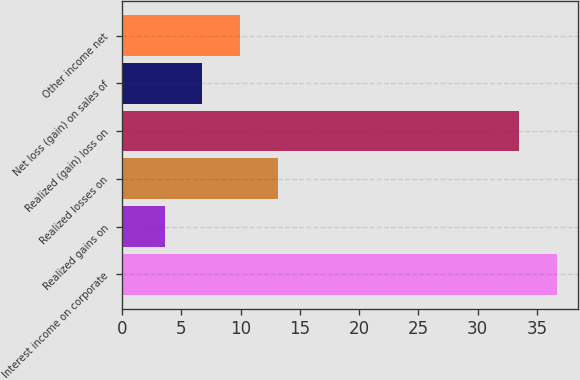Convert chart to OTSL. <chart><loc_0><loc_0><loc_500><loc_500><bar_chart><fcel>Interest income on corporate<fcel>Realized gains on<fcel>Realized losses on<fcel>Realized (gain) loss on<fcel>Net loss (gain) on sales of<fcel>Other income net<nl><fcel>36.68<fcel>3.6<fcel>13.14<fcel>33.5<fcel>6.78<fcel>9.96<nl></chart> 